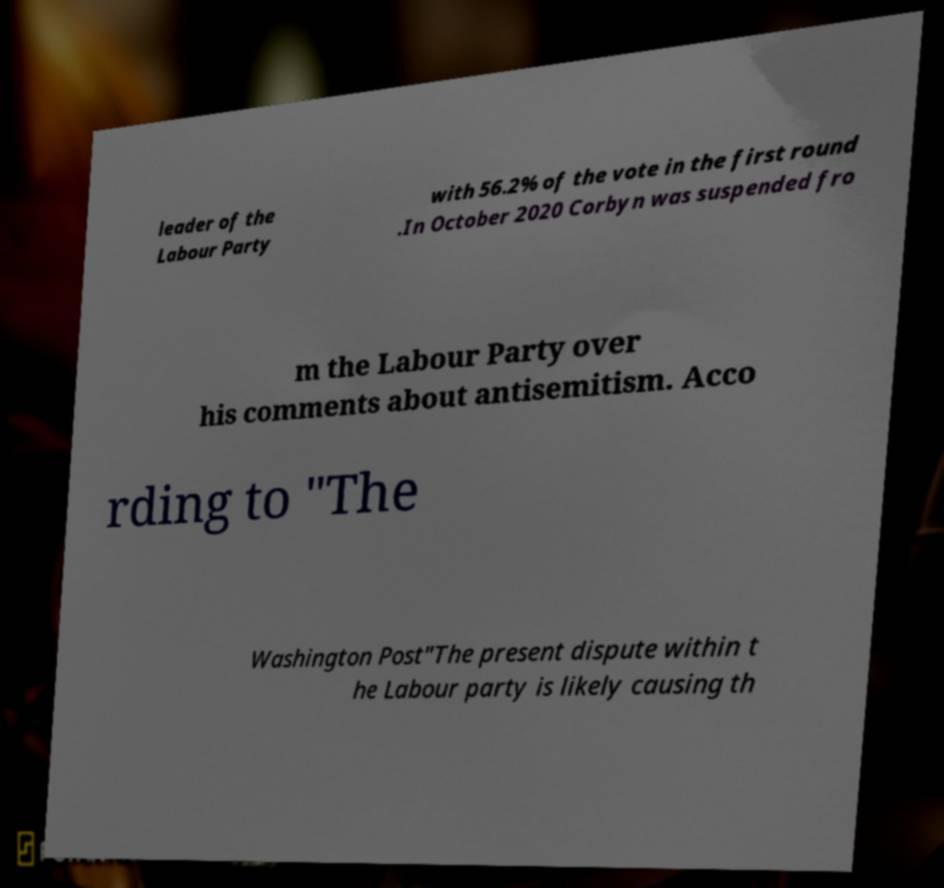Please read and relay the text visible in this image. What does it say? leader of the Labour Party with 56.2% of the vote in the first round .In October 2020 Corbyn was suspended fro m the Labour Party over his comments about antisemitism. Acco rding to "The Washington Post"The present dispute within t he Labour party is likely causing th 